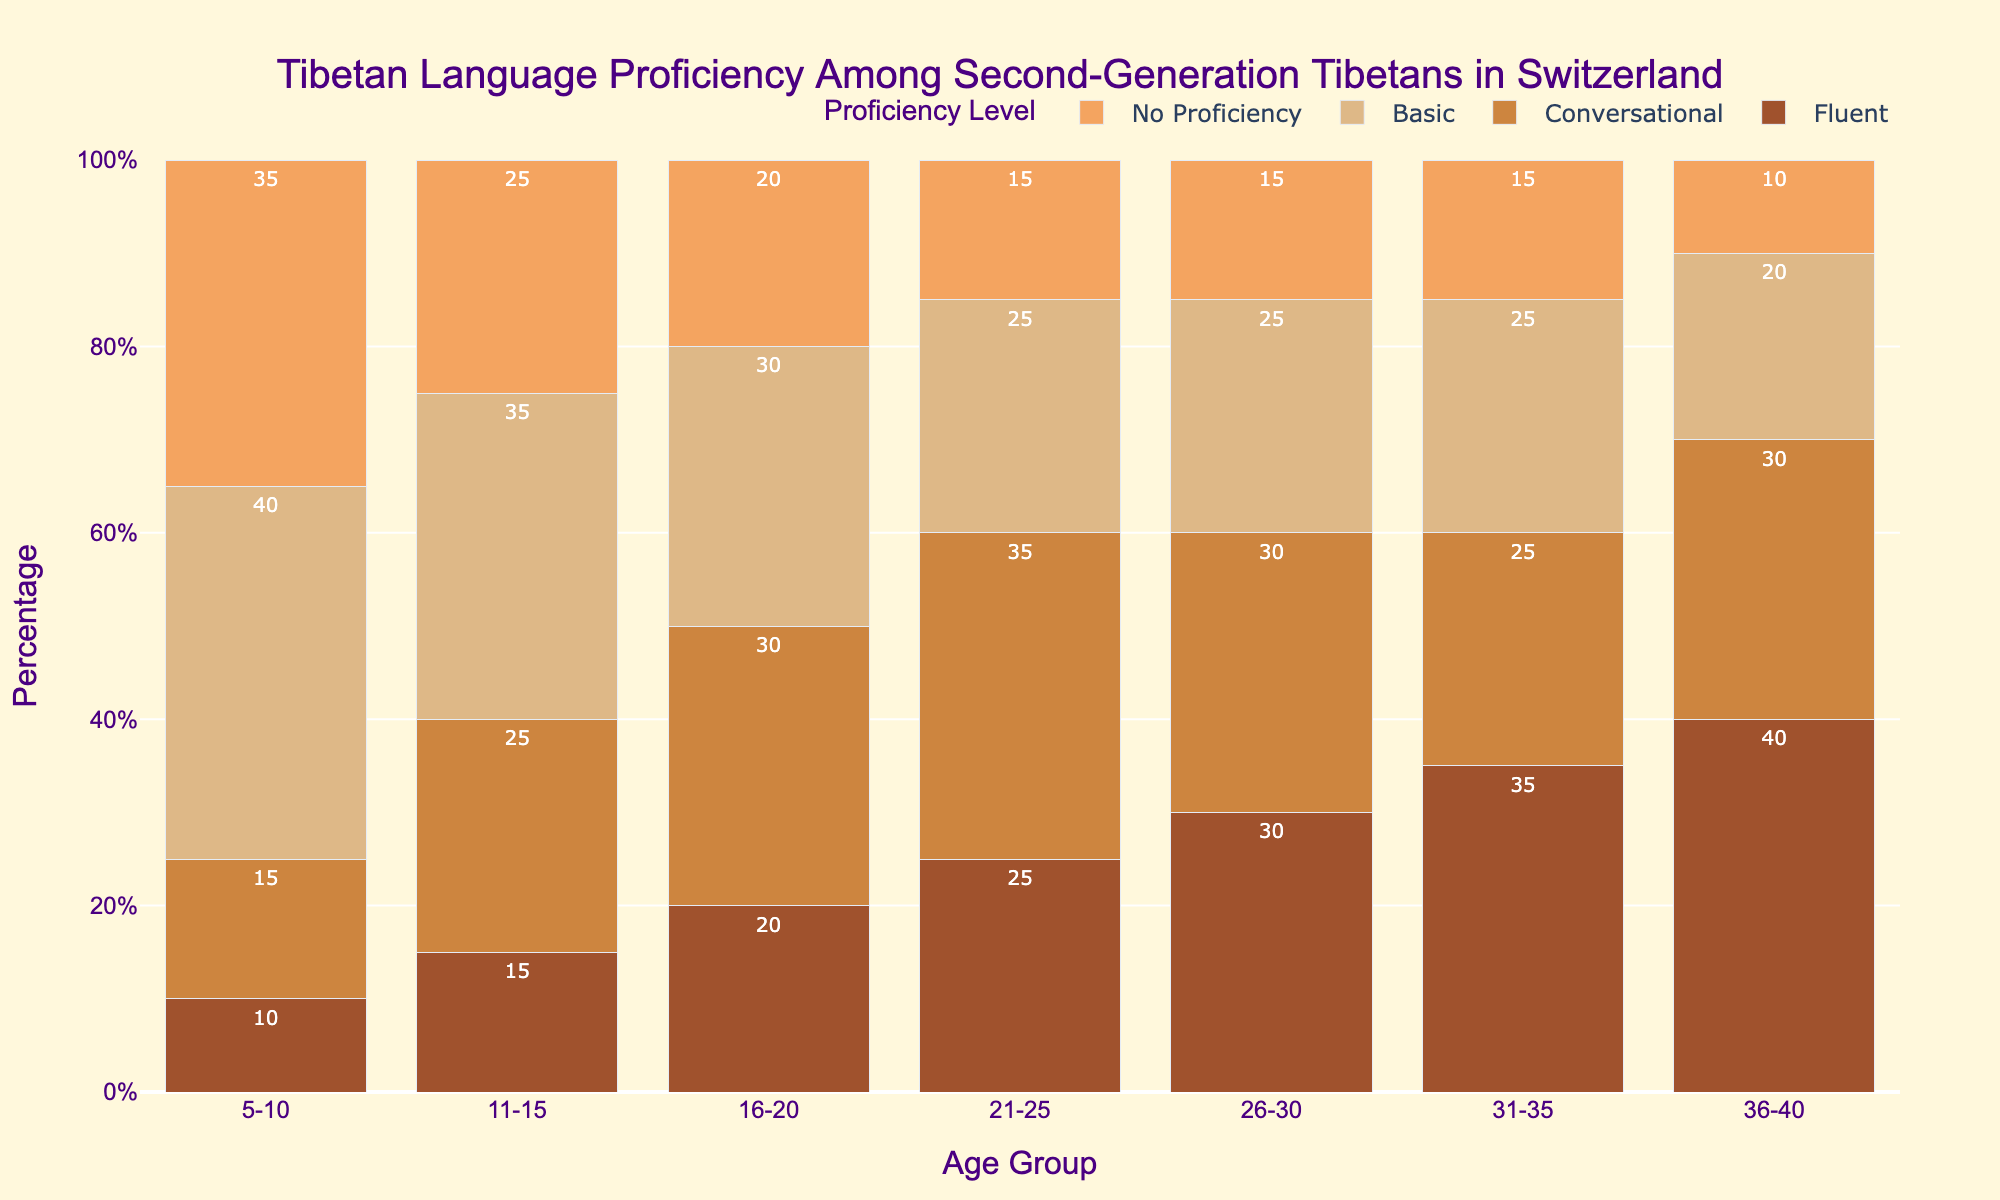Which age group has the highest percentage of fluent speakers? By visually inspecting the height of the bars in the "Fluent" category, the tallest bar corresponds to the age group 36-40.
Answer: 36-40 What is the total percentage of people with basic proficiency in the 5-10 and 11-15 age groups combined? Add the percentage of people with basic proficiency in the 5-10 age group (40%) to those in the 11-15 age group (35%). 40 + 35 = 75
Answer: 75% Compare the percentage of people with no proficiency between the age groups 21-25 and 26-30. Which age group has a lower percentage? By comparing the bars for "No Proficiency" in these two age groups, 21-25 has a bar height of 15%, and 26-30 also has a bar height of 15%. Both are equal.
Answer: Both are equal What is the difference in the percentage of conversational speakers between age groups 16-20 and 31-35? Subtract the percentage of conversational speakers in the 31-35 age group (25%) from those in the 16-20 age group (30%). 30 - 25 = 5
Answer: 5% Which proficiency level has the most consistent percentage across all age groups? By visually inspecting the bar heights for each proficiency level, "Basic" shows the most consistent percentages across all age groups.
Answer: Basic In which age group is the combined percentage of fluent and conversational speakers the highest? Add the percentages for "Fluent" and "Conversational" for each age group and find the highest sum:
- 5-10: 10 + 15 = 25
- 11-15: 15 + 25 = 40
- 16-20: 20 + 30 = 50
- 21-25: 25 + 35 = 60
- 26-30: 30 + 30 = 60
- 31-35: 35 + 25 = 60
- 36-40: 40 + 30 = 70
The highest combined percentage is for the 36-40 age group.
Answer: 36-40 Which proficiency level decreases steadily from the youngest to the oldest age group? By visually inspecting the bar heights, the bars corresponding to "No Proficiency" steadily decrease from the youngest to the oldest age group.
Answer: No Proficiency How does the percentage of people with no proficiency change from age group 5-10 to 36-40? For age group 5-10, the percentage is 35%, and for 36-40, it is 10%. So the change is 35% - 10% = 25% decrease.
Answer: 25% decrease What is the average percentage of conversational speakers across all age groups? Sum the percentages of conversational speakers for all age groups and divide by the number of age groups:
(15 + 25 + 30 + 35 + 30 + 25 + 30) / 7 = 190 / 7 ≈ 27.14
Answer: 27.14% 